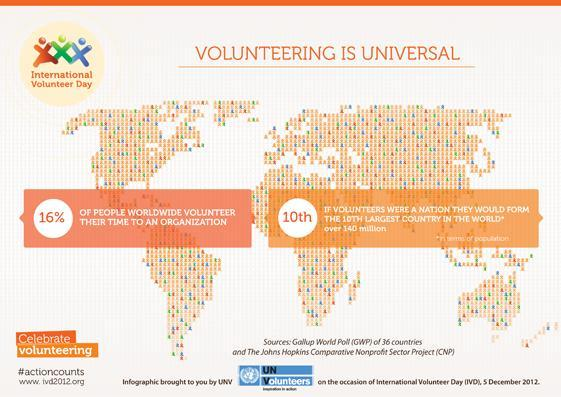what is the count of volunteers
Answer the question with a short phrase. 140 million Which day is being celebrated International Volunteer Day 